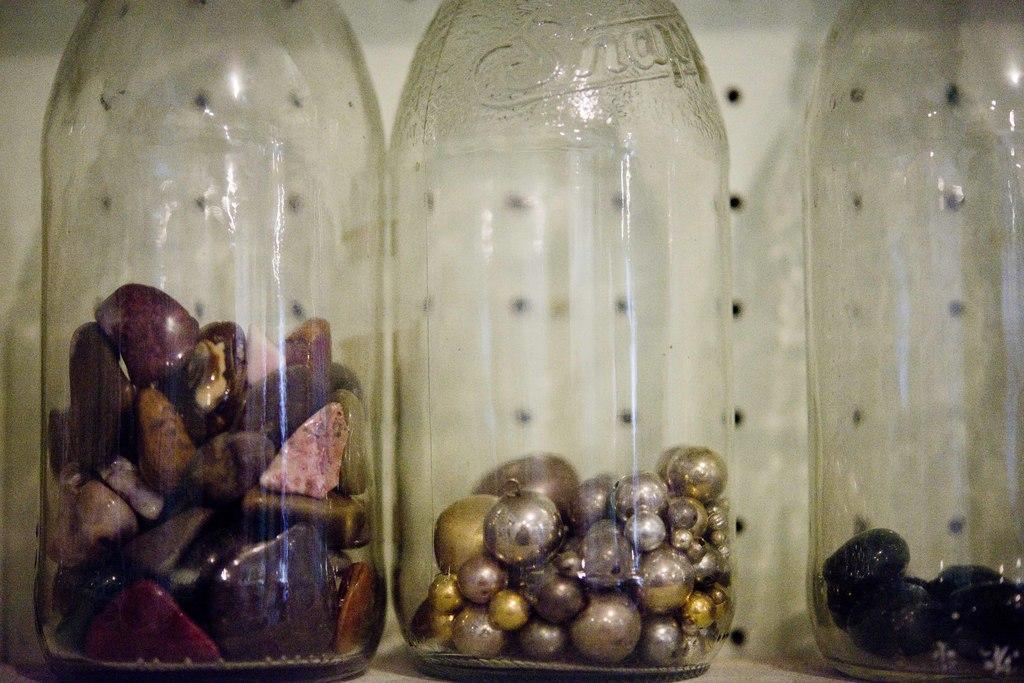<image>
Relay a brief, clear account of the picture shown. jars full of different items like rocks and balls 